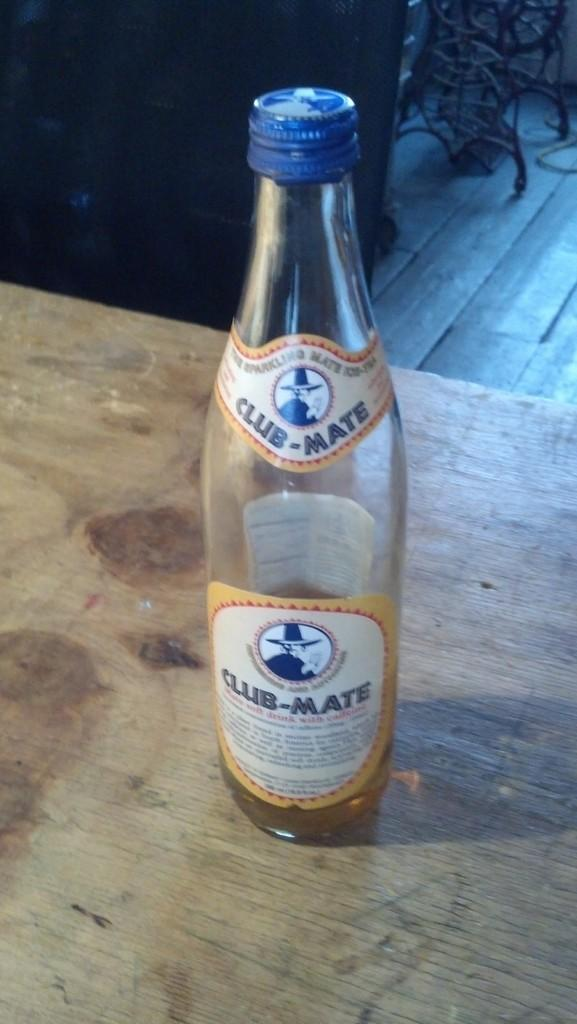<image>
Write a terse but informative summary of the picture. A Club-Mate bottle sits on a wood table. 